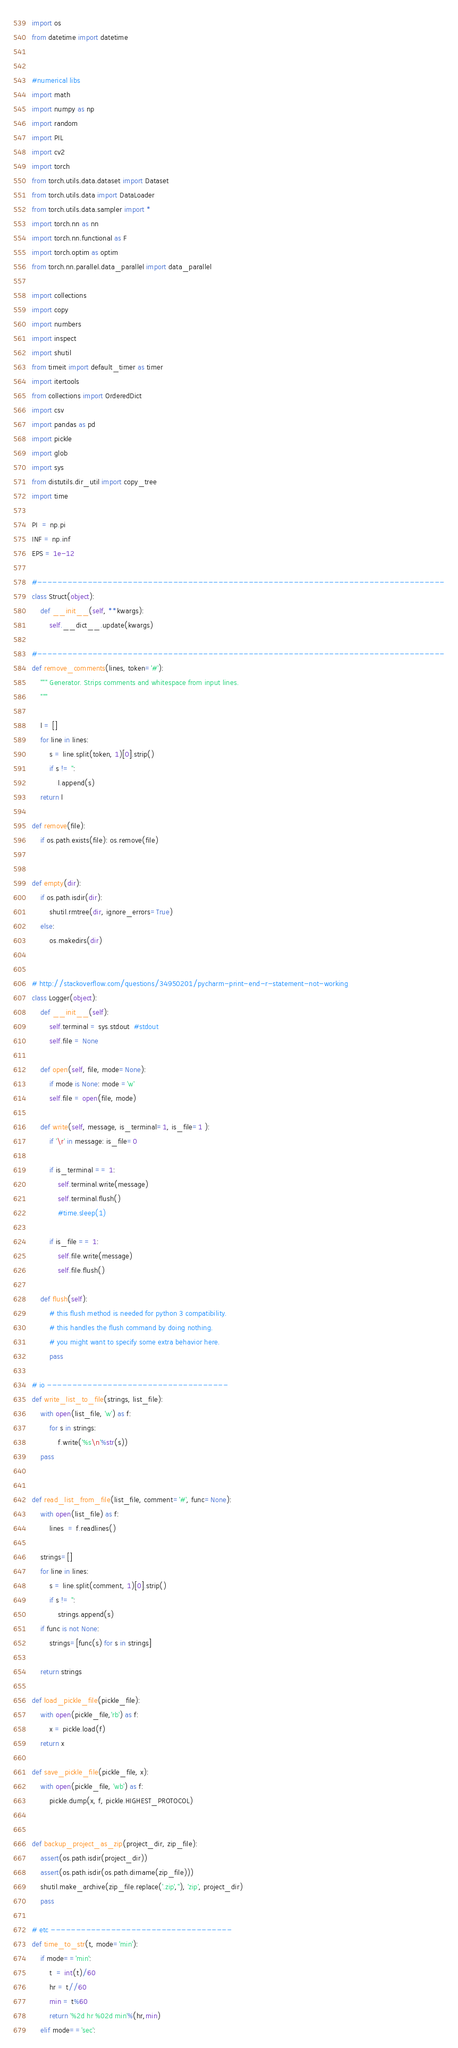Convert code to text. <code><loc_0><loc_0><loc_500><loc_500><_Python_>
import os
from datetime import datetime


#numerical libs
import math
import numpy as np
import random
import PIL
import cv2
import torch
from torch.utils.data.dataset import Dataset
from torch.utils.data import DataLoader
from torch.utils.data.sampler import *
import torch.nn as nn
import torch.nn.functional as F
import torch.optim as optim
from torch.nn.parallel.data_parallel import data_parallel

import collections
import copy
import numbers
import inspect
import shutil
from timeit import default_timer as timer
import itertools
from collections import OrderedDict
import csv
import pandas as pd
import pickle
import glob
import sys
from distutils.dir_util import copy_tree
import time

PI  = np.pi
INF = np.inf
EPS = 1e-12

#---------------------------------------------------------------------------------
class Struct(object):
    def __init__(self, **kwargs):
        self.__dict__.update(kwargs)

#---------------------------------------------------------------------------------
def remove_comments(lines, token='#'):
    """ Generator. Strips comments and whitespace from input lines.
    """

    l = []
    for line in lines:
        s = line.split(token, 1)[0].strip()
        if s != '':
            l.append(s)
    return l

def remove(file):
    if os.path.exists(file): os.remove(file)


def empty(dir):
    if os.path.isdir(dir):
        shutil.rmtree(dir, ignore_errors=True)
    else:
        os.makedirs(dir)


# http://stackoverflow.com/questions/34950201/pycharm-print-end-r-statement-not-working
class Logger(object):
    def __init__(self):
        self.terminal = sys.stdout  #stdout
        self.file = None

    def open(self, file, mode=None):
        if mode is None: mode ='w'
        self.file = open(file, mode)

    def write(self, message, is_terminal=1, is_file=1 ):
        if '\r' in message: is_file=0

        if is_terminal == 1:
            self.terminal.write(message)
            self.terminal.flush()
            #time.sleep(1)

        if is_file == 1:
            self.file.write(message)
            self.file.flush()

    def flush(self):
        # this flush method is needed for python 3 compatibility.
        # this handles the flush command by doing nothing.
        # you might want to specify some extra behavior here.
        pass

# io ------------------------------------
def write_list_to_file(strings, list_file):
    with open(list_file, 'w') as f:
        for s in strings:
            f.write('%s\n'%str(s))
    pass


def read_list_from_file(list_file, comment='#', func=None):
    with open(list_file) as f:
        lines  = f.readlines()

    strings=[]
    for line in lines:
        s = line.split(comment, 1)[0].strip()
        if s != '':
            strings.append(s)
    if func is not None:
        strings=[func(s) for s in strings]

    return strings

def load_pickle_file(pickle_file):
    with open(pickle_file,'rb') as f:
        x = pickle.load(f)
    return x

def save_pickle_file(pickle_file, x):
    with open(pickle_file, 'wb') as f:
        pickle.dump(x, f, pickle.HIGHEST_PROTOCOL)


def backup_project_as_zip(project_dir, zip_file):
    assert(os.path.isdir(project_dir))
    assert(os.path.isdir(os.path.dirname(zip_file)))
    shutil.make_archive(zip_file.replace('.zip',''), 'zip', project_dir)
    pass

# etc ------------------------------------
def time_to_str(t, mode='min'):
    if mode=='min':
        t  = int(t)/60
        hr = t//60
        min = t%60
        return '%2d hr %02d min'%(hr,min)
    elif mode=='sec':</code> 